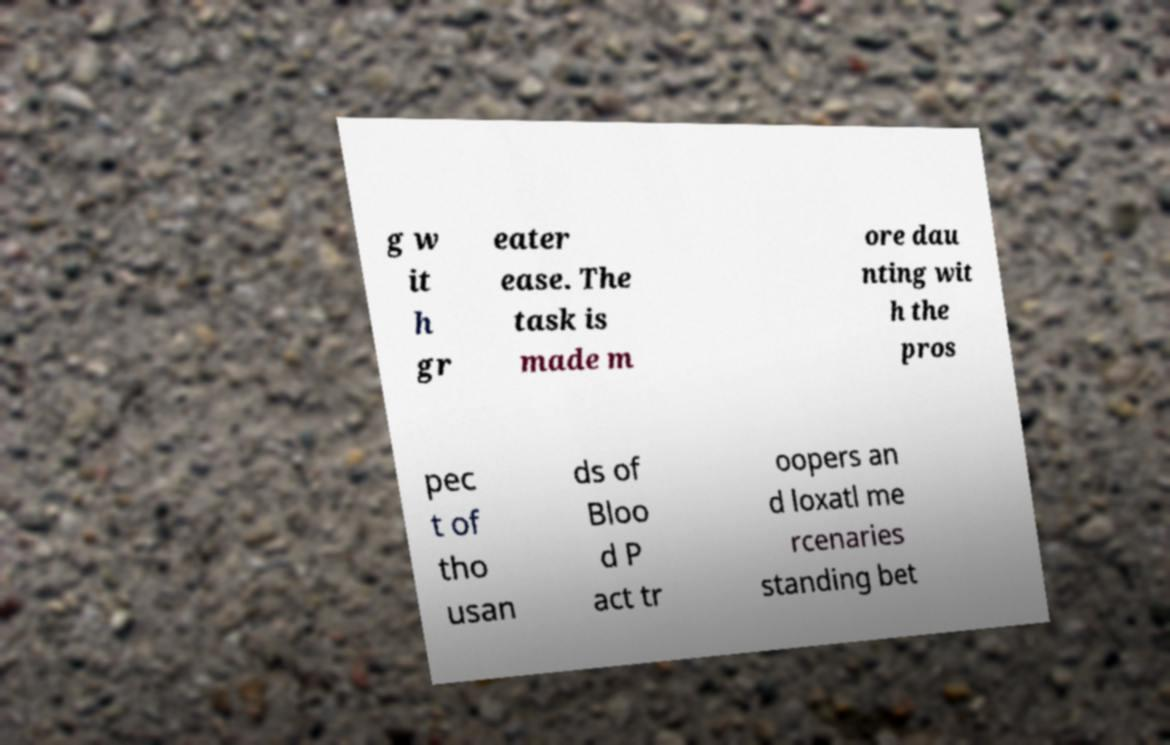There's text embedded in this image that I need extracted. Can you transcribe it verbatim? g w it h gr eater ease. The task is made m ore dau nting wit h the pros pec t of tho usan ds of Bloo d P act tr oopers an d loxatl me rcenaries standing bet 